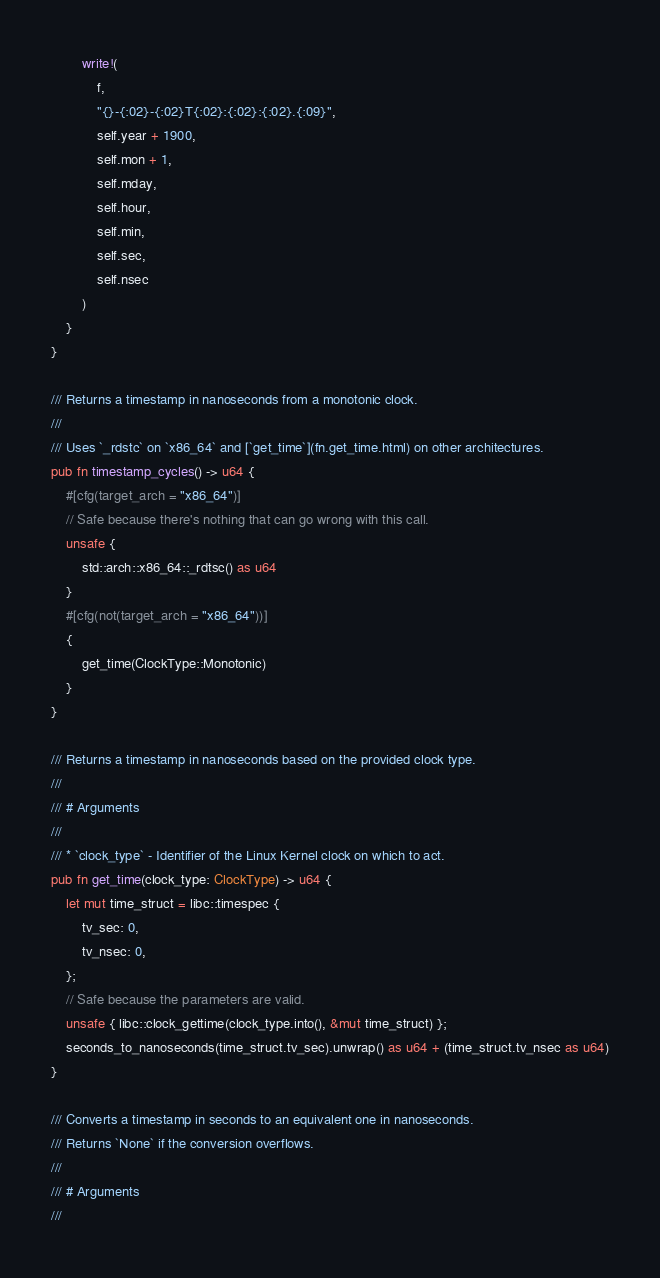<code> <loc_0><loc_0><loc_500><loc_500><_Rust_>        write!(
            f,
            "{}-{:02}-{:02}T{:02}:{:02}:{:02}.{:09}",
            self.year + 1900,
            self.mon + 1,
            self.mday,
            self.hour,
            self.min,
            self.sec,
            self.nsec
        )
    }
}

/// Returns a timestamp in nanoseconds from a monotonic clock.
///
/// Uses `_rdstc` on `x86_64` and [`get_time`](fn.get_time.html) on other architectures.
pub fn timestamp_cycles() -> u64 {
    #[cfg(target_arch = "x86_64")]
    // Safe because there's nothing that can go wrong with this call.
    unsafe {
        std::arch::x86_64::_rdtsc() as u64
    }
    #[cfg(not(target_arch = "x86_64"))]
    {
        get_time(ClockType::Monotonic)
    }
}

/// Returns a timestamp in nanoseconds based on the provided clock type.
///
/// # Arguments
///
/// * `clock_type` - Identifier of the Linux Kernel clock on which to act.
pub fn get_time(clock_type: ClockType) -> u64 {
    let mut time_struct = libc::timespec {
        tv_sec: 0,
        tv_nsec: 0,
    };
    // Safe because the parameters are valid.
    unsafe { libc::clock_gettime(clock_type.into(), &mut time_struct) };
    seconds_to_nanoseconds(time_struct.tv_sec).unwrap() as u64 + (time_struct.tv_nsec as u64)
}

/// Converts a timestamp in seconds to an equivalent one in nanoseconds.
/// Returns `None` if the conversion overflows.
///
/// # Arguments
///</code> 